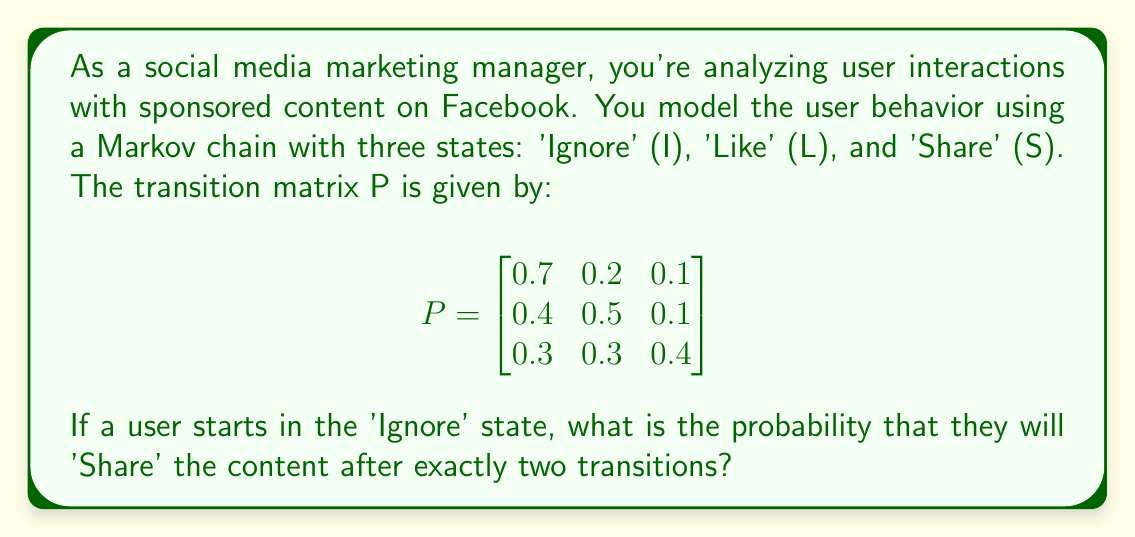Could you help me with this problem? To solve this problem, we need to use the properties of Markov chains and matrix multiplication. We're looking for the probability of going from state I to state S in exactly two steps.

Step 1: Identify the initial state vector.
The initial state vector is $v_0 = [1, 0, 0]$ since we start in the 'Ignore' state.

Step 2: Calculate the two-step transition matrix.
We need to multiply the transition matrix by itself: $P^2 = P \times P$

$$P^2 = \begin{bmatrix}
0.7 & 0.2 & 0.1 \\
0.4 & 0.5 & 0.1 \\
0.3 & 0.3 & 0.4
\end{bmatrix} \times 
\begin{bmatrix}
0.7 & 0.2 & 0.1 \\
0.4 & 0.5 & 0.1 \\
0.3 & 0.3 & 0.4
\end{bmatrix}$$

Step 3: Perform the matrix multiplication.
$$P^2 = \begin{bmatrix}
0.61 & 0.26 & 0.13 \\
0.53 & 0.33 & 0.14 \\
0.43 & 0.33 & 0.24
\end{bmatrix}$$

Step 4: Identify the probability of moving from 'Ignore' to 'Share' in two steps.
This probability is given by the element in the first row, third column of $P^2$, which is 0.13.

Therefore, the probability of a user starting in the 'Ignore' state and ending in the 'Share' state after exactly two transitions is 0.13 or 13%.
Answer: 0.13 